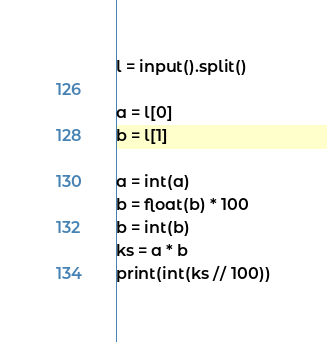<code> <loc_0><loc_0><loc_500><loc_500><_Python_>l = input().split()
 
a = l[0]
b = l[1]
 
a = int(a)
b = float(b) * 100
b = int(b)
ks = a * b 
print(int(ks // 100))</code> 